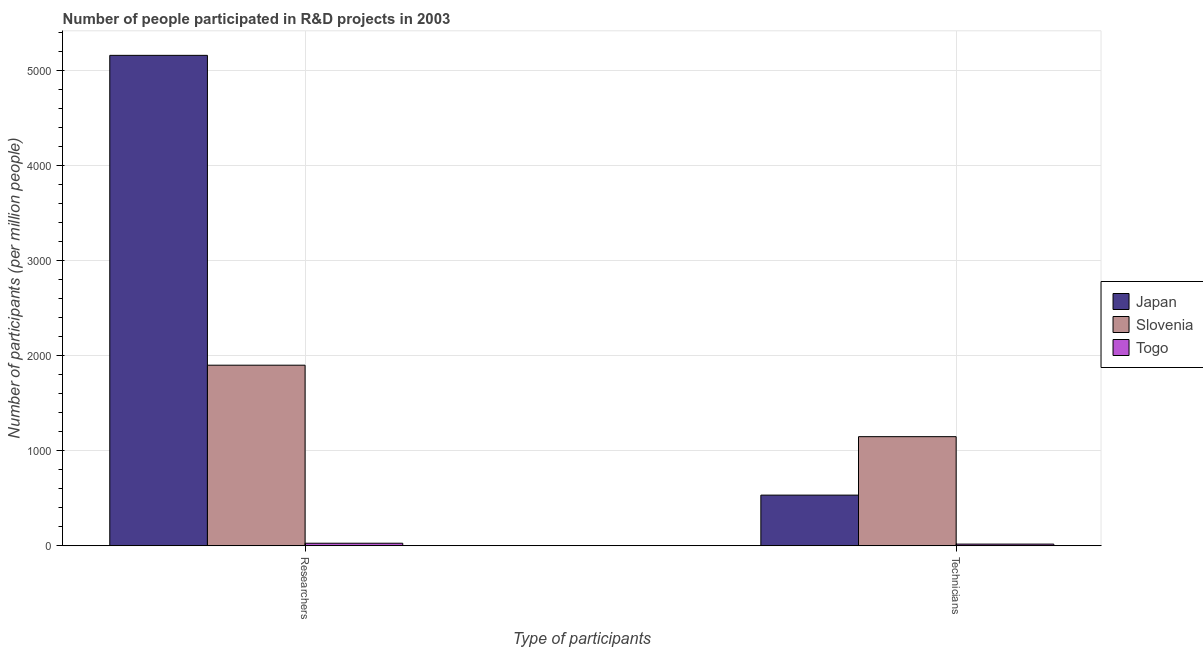Are the number of bars on each tick of the X-axis equal?
Your answer should be very brief. Yes. How many bars are there on the 2nd tick from the right?
Keep it short and to the point. 3. What is the label of the 1st group of bars from the left?
Offer a terse response. Researchers. What is the number of researchers in Slovenia?
Offer a terse response. 1898.6. Across all countries, what is the maximum number of researchers?
Provide a short and direct response. 5156.09. Across all countries, what is the minimum number of researchers?
Your response must be concise. 26.88. In which country was the number of technicians maximum?
Your answer should be compact. Slovenia. In which country was the number of researchers minimum?
Make the answer very short. Togo. What is the total number of technicians in the graph?
Provide a succinct answer. 1697.43. What is the difference between the number of technicians in Slovenia and that in Japan?
Ensure brevity in your answer.  614.59. What is the difference between the number of researchers in Togo and the number of technicians in Japan?
Offer a terse response. -505.74. What is the average number of researchers per country?
Offer a terse response. 2360.52. What is the difference between the number of researchers and number of technicians in Japan?
Provide a short and direct response. 4623.47. What is the ratio of the number of technicians in Togo to that in Slovenia?
Keep it short and to the point. 0.02. What does the 2nd bar from the left in Researchers represents?
Provide a succinct answer. Slovenia. What does the 2nd bar from the right in Technicians represents?
Ensure brevity in your answer.  Slovenia. Does the graph contain any zero values?
Your answer should be compact. No. Does the graph contain grids?
Provide a short and direct response. Yes. How many legend labels are there?
Offer a terse response. 3. How are the legend labels stacked?
Give a very brief answer. Vertical. What is the title of the graph?
Your answer should be compact. Number of people participated in R&D projects in 2003. Does "Slovenia" appear as one of the legend labels in the graph?
Keep it short and to the point. Yes. What is the label or title of the X-axis?
Your response must be concise. Type of participants. What is the label or title of the Y-axis?
Offer a very short reply. Number of participants (per million people). What is the Number of participants (per million people) of Japan in Researchers?
Your response must be concise. 5156.09. What is the Number of participants (per million people) of Slovenia in Researchers?
Provide a short and direct response. 1898.6. What is the Number of participants (per million people) of Togo in Researchers?
Your answer should be very brief. 26.88. What is the Number of participants (per million people) in Japan in Technicians?
Your response must be concise. 532.62. What is the Number of participants (per million people) in Slovenia in Technicians?
Give a very brief answer. 1147.21. What is the Number of participants (per million people) in Togo in Technicians?
Your answer should be compact. 17.6. Across all Type of participants, what is the maximum Number of participants (per million people) in Japan?
Offer a very short reply. 5156.09. Across all Type of participants, what is the maximum Number of participants (per million people) of Slovenia?
Give a very brief answer. 1898.6. Across all Type of participants, what is the maximum Number of participants (per million people) of Togo?
Your answer should be compact. 26.88. Across all Type of participants, what is the minimum Number of participants (per million people) in Japan?
Offer a terse response. 532.62. Across all Type of participants, what is the minimum Number of participants (per million people) of Slovenia?
Make the answer very short. 1147.21. Across all Type of participants, what is the minimum Number of participants (per million people) in Togo?
Offer a terse response. 17.6. What is the total Number of participants (per million people) in Japan in the graph?
Offer a terse response. 5688.71. What is the total Number of participants (per million people) of Slovenia in the graph?
Your response must be concise. 3045.81. What is the total Number of participants (per million people) of Togo in the graph?
Offer a terse response. 44.48. What is the difference between the Number of participants (per million people) in Japan in Researchers and that in Technicians?
Your answer should be very brief. 4623.47. What is the difference between the Number of participants (per million people) of Slovenia in Researchers and that in Technicians?
Give a very brief answer. 751.39. What is the difference between the Number of participants (per million people) of Togo in Researchers and that in Technicians?
Your response must be concise. 9.27. What is the difference between the Number of participants (per million people) in Japan in Researchers and the Number of participants (per million people) in Slovenia in Technicians?
Ensure brevity in your answer.  4008.88. What is the difference between the Number of participants (per million people) in Japan in Researchers and the Number of participants (per million people) in Togo in Technicians?
Make the answer very short. 5138.49. What is the difference between the Number of participants (per million people) of Slovenia in Researchers and the Number of participants (per million people) of Togo in Technicians?
Ensure brevity in your answer.  1881. What is the average Number of participants (per million people) of Japan per Type of participants?
Provide a succinct answer. 2844.36. What is the average Number of participants (per million people) in Slovenia per Type of participants?
Keep it short and to the point. 1522.91. What is the average Number of participants (per million people) of Togo per Type of participants?
Make the answer very short. 22.24. What is the difference between the Number of participants (per million people) in Japan and Number of participants (per million people) in Slovenia in Researchers?
Make the answer very short. 3257.49. What is the difference between the Number of participants (per million people) in Japan and Number of participants (per million people) in Togo in Researchers?
Keep it short and to the point. 5129.22. What is the difference between the Number of participants (per million people) of Slovenia and Number of participants (per million people) of Togo in Researchers?
Provide a succinct answer. 1871.73. What is the difference between the Number of participants (per million people) in Japan and Number of participants (per million people) in Slovenia in Technicians?
Offer a terse response. -614.59. What is the difference between the Number of participants (per million people) in Japan and Number of participants (per million people) in Togo in Technicians?
Your answer should be very brief. 515.02. What is the difference between the Number of participants (per million people) in Slovenia and Number of participants (per million people) in Togo in Technicians?
Your answer should be very brief. 1129.61. What is the ratio of the Number of participants (per million people) of Japan in Researchers to that in Technicians?
Keep it short and to the point. 9.68. What is the ratio of the Number of participants (per million people) of Slovenia in Researchers to that in Technicians?
Offer a terse response. 1.66. What is the ratio of the Number of participants (per million people) in Togo in Researchers to that in Technicians?
Your answer should be compact. 1.53. What is the difference between the highest and the second highest Number of participants (per million people) in Japan?
Offer a very short reply. 4623.47. What is the difference between the highest and the second highest Number of participants (per million people) in Slovenia?
Offer a terse response. 751.39. What is the difference between the highest and the second highest Number of participants (per million people) in Togo?
Your answer should be very brief. 9.27. What is the difference between the highest and the lowest Number of participants (per million people) of Japan?
Your answer should be compact. 4623.47. What is the difference between the highest and the lowest Number of participants (per million people) of Slovenia?
Offer a very short reply. 751.39. What is the difference between the highest and the lowest Number of participants (per million people) in Togo?
Your response must be concise. 9.27. 